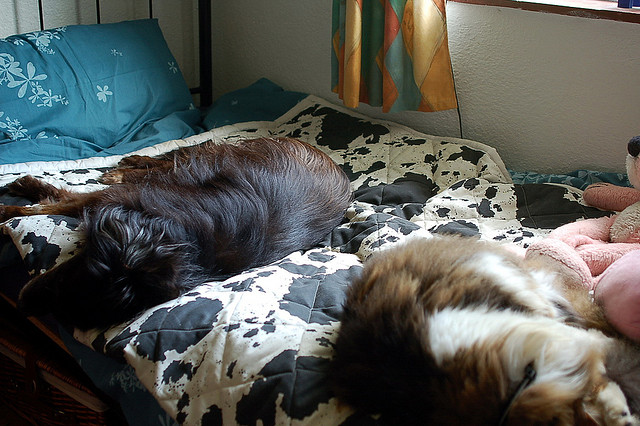<image>What pattern is on the blanket? I don't know the exact pattern on the blanket. It could be cow print, splotches, blotch, or spotted like cow. What pattern is on the blanket? I am not sure what pattern is on the blanket. It could be cow print, country shapes, splotches, or spotted like cow. 